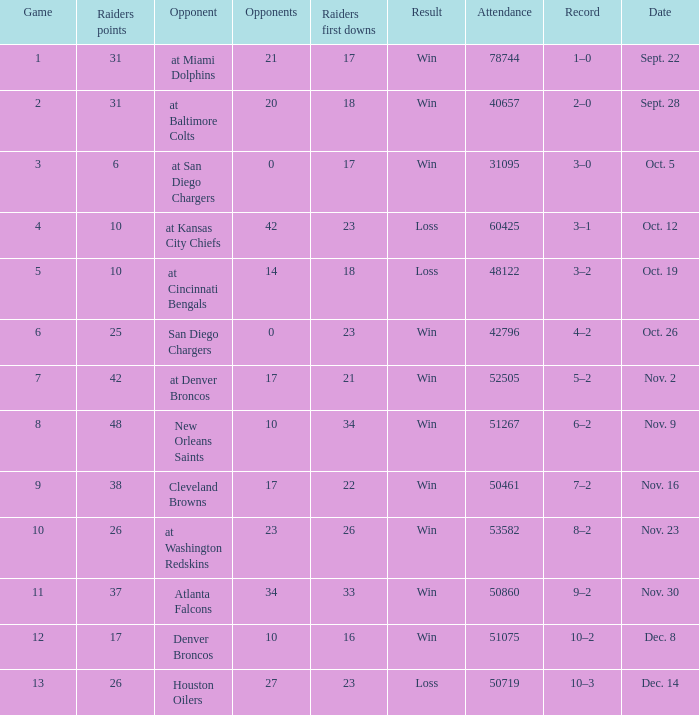Who was the game attended by 60425 people played against? At kansas city chiefs. 